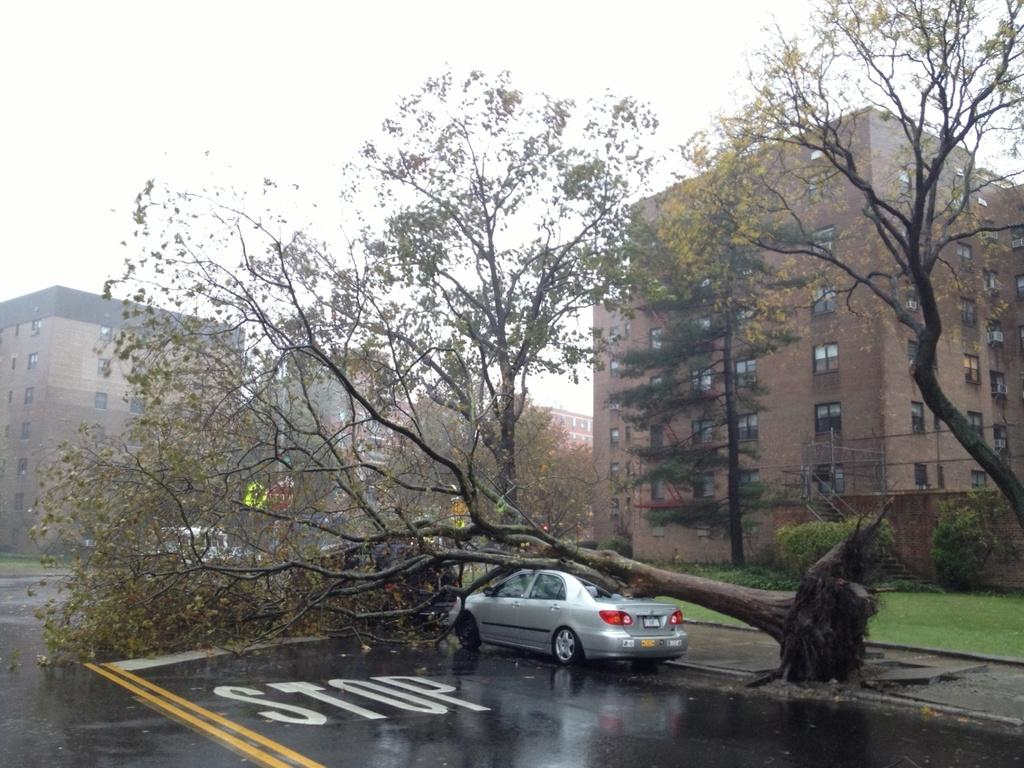What is located at the bottom of the image? There is a road at the bottom of the image. What can be seen in the background of the image? There are buildings in the background of the image. What type of vegetation is present in the image? There are trees in the image. What mode of transportation can be seen in the image? There is a car in the image. What type of ground cover is on the right side of the image? There is grass on the right side of the image. How many patches of oil can be seen on the road in the image? There is no mention of oil patches on the road in the image, so it cannot be determined from the provided facts. How many men are visible in the image? There is no mention of men in the image, so it cannot be determined from the provided facts. 